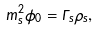<formula> <loc_0><loc_0><loc_500><loc_500>m _ { s } ^ { 2 } \phi _ { 0 } = \Gamma _ { s } \rho _ { s } ,</formula> 